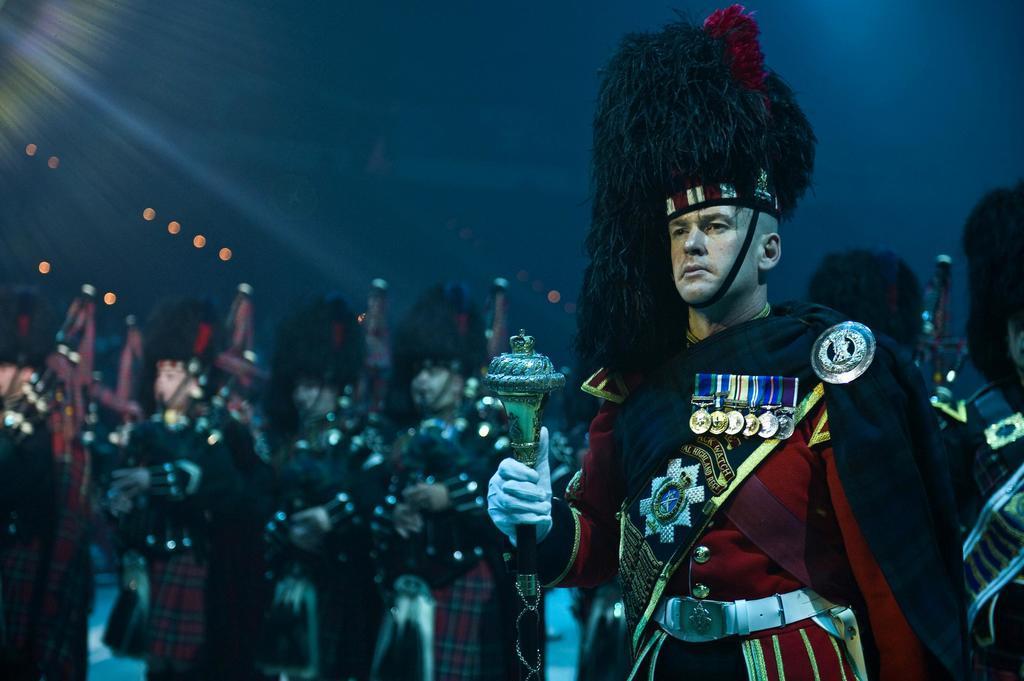Can you describe this image briefly? In this image there is one person standing on the right side of this image is holding an object. There are some other persons standing in the background. 